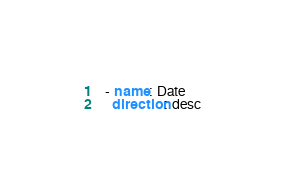<code> <loc_0><loc_0><loc_500><loc_500><_YAML_>  - name: Date
    direction: desc
</code> 